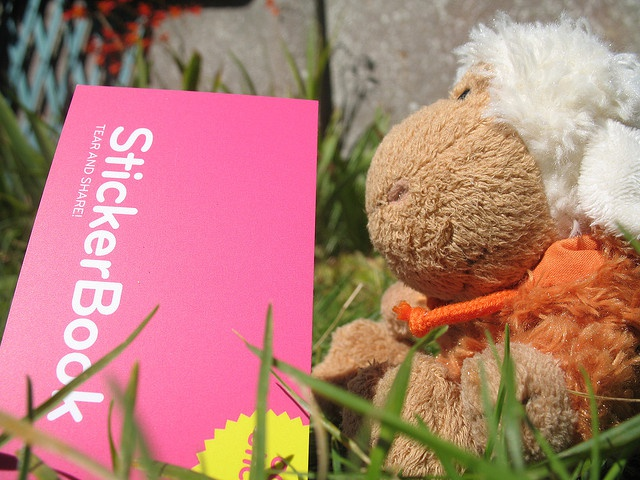Describe the objects in this image and their specific colors. I can see book in black, violet, lightpink, and white tones and teddy bear in black, lightgray, tan, and brown tones in this image. 